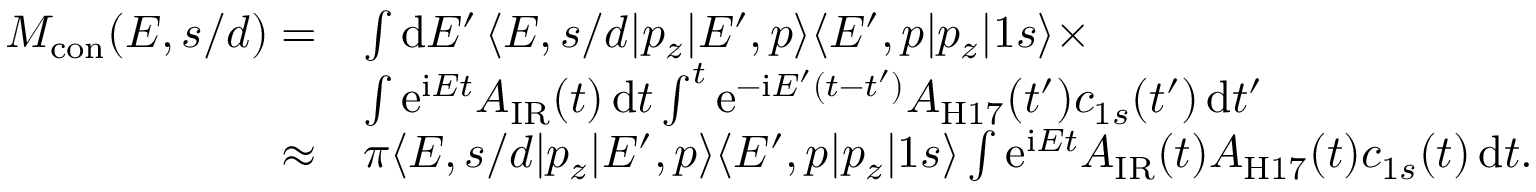<formula> <loc_0><loc_0><loc_500><loc_500>\begin{array} { r l } { M _ { c o n } ( E , s / d ) = } & { \int \mathrm d E ^ { \prime } \, \langle E , s / d | p _ { z } | E ^ { \prime } , p \rangle \langle E ^ { \prime } , p | p _ { z } | 1 s \rangle \times } \\ & { \int \mathrm e ^ { \mathrm i E t } A _ { I R } ( t ) \, \mathrm d t \int ^ { t } \mathrm e ^ { - \mathrm i E ^ { \prime } ( t - t ^ { \prime } ) } A _ { H 1 7 } ( t ^ { \prime } ) c _ { 1 s } ( t ^ { \prime } ) \, \mathrm d t ^ { \prime } } \\ { \approx } & { \pi \langle E , s / d | p _ { z } | E ^ { \prime } , p \rangle \langle E ^ { \prime } , p | p _ { z } | 1 s \rangle \int \mathrm e ^ { \mathrm i E t } A _ { I R } ( t ) A _ { H 1 7 } ( t ) c _ { 1 s } ( t ) \, \mathrm d t . } \end{array}</formula> 